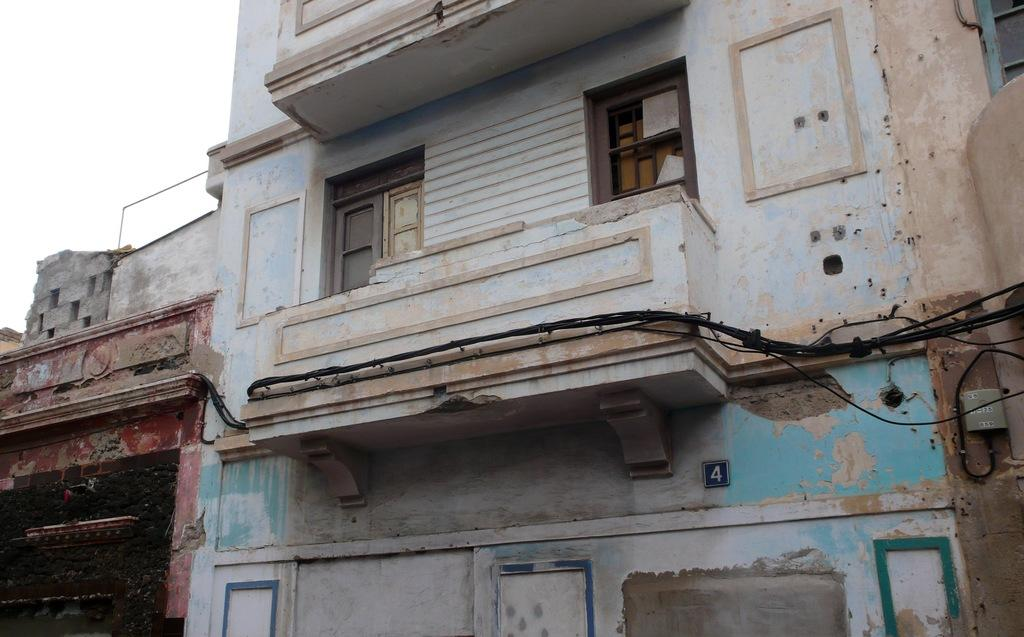What objects can be seen in the image related to water or fluid transportation? There are hoses in the image. What type of structure is present in the image? There is a wall in the image. What other objects can be seen in the image related to electrical connections? There are wires in the image. What architectural feature is visible in the image that allows for natural light and ventilation? There is a window in the image. What object with a unique identifier can be seen in the image? A number plate is visible in the image. What part of the natural environment is visible in the image? The sky is visible at the top left side of the image. How many bikes are parked near the wall in the image? There is no mention of bikes in the image, so it is impossible to determine the number of bikes present. What type of plot is being developed in the image? There is no indication of a plot or development project in the image. 